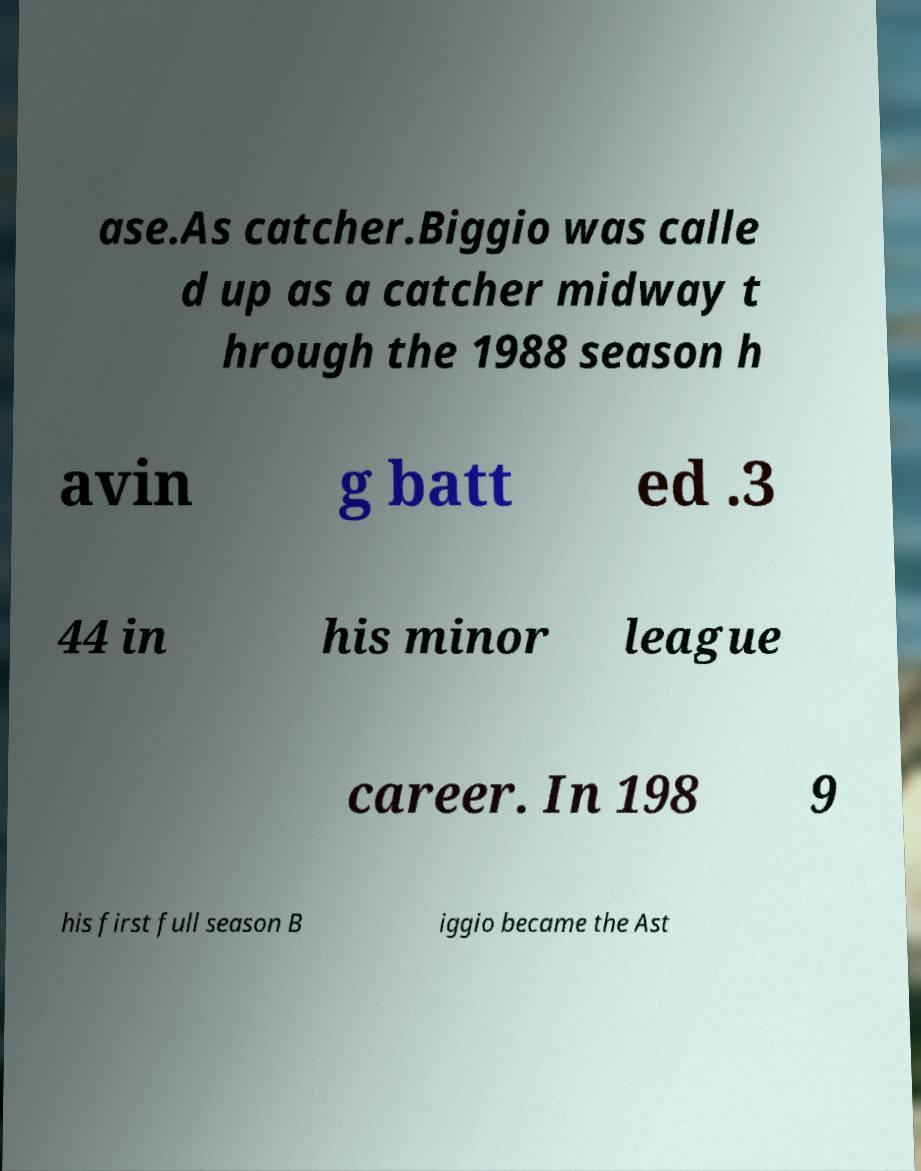There's text embedded in this image that I need extracted. Can you transcribe it verbatim? ase.As catcher.Biggio was calle d up as a catcher midway t hrough the 1988 season h avin g batt ed .3 44 in his minor league career. In 198 9 his first full season B iggio became the Ast 